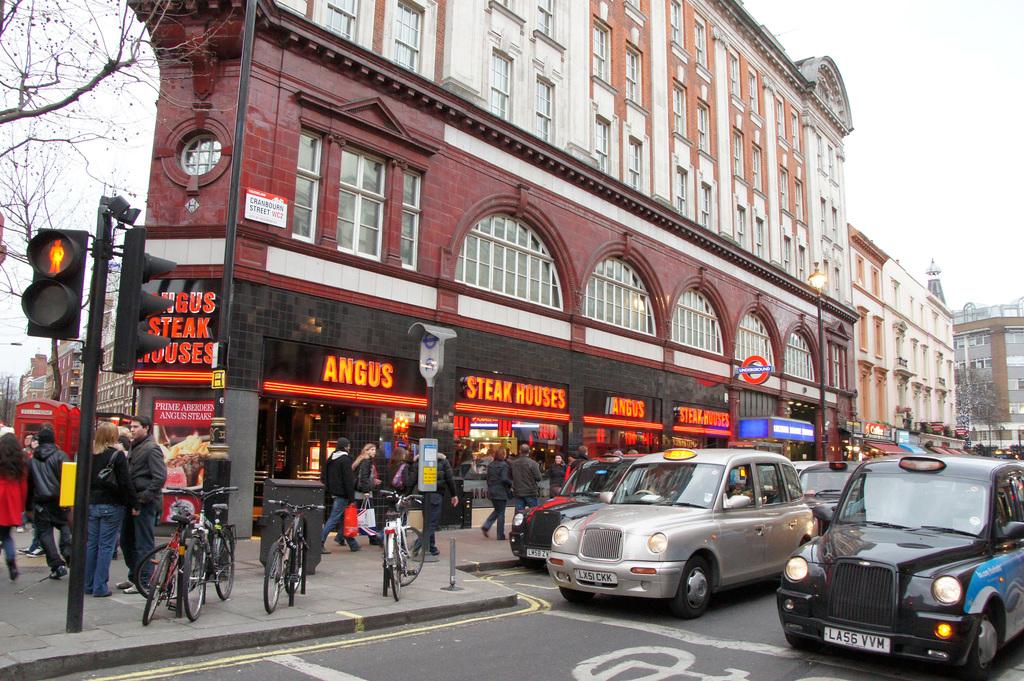What does that restaurant serve?
Make the answer very short. Steak. What is the license plate number on the black car to the right?
Offer a very short reply. La56 vvm. 